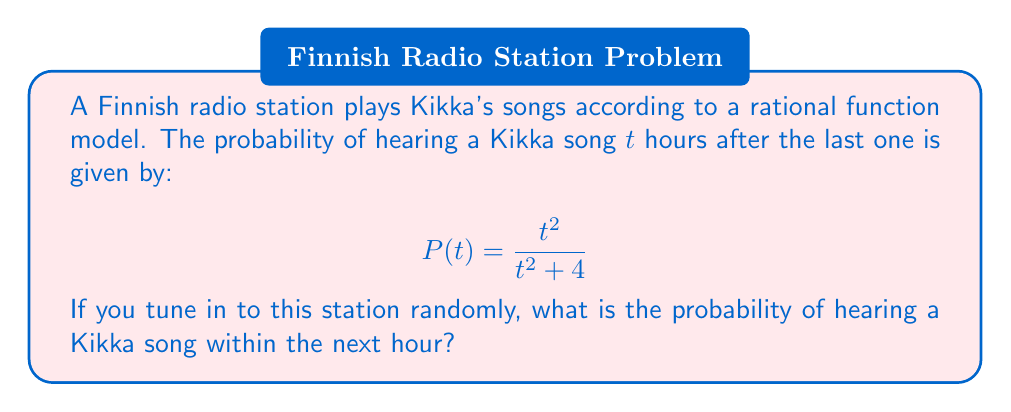Help me with this question. To solve this problem, we need to integrate the probability function over the interval from 0 to 1 hour:

1) The integral we need to calculate is:

   $$\int_0^1 P(t) dt = \int_0^1 \frac{t^2}{t^2 + 4} dt$$

2) This integral can be solved using the substitution method. Let $u = t^2 + 4$, then $du = 2t dt$ or $dt = \frac{du}{2t}$:

   $$\int_0^1 \frac{t^2}{t^2 + 4} dt = \frac{1}{2}\int_4^5 \frac{u-4}{u} du$$

3) This can be further simplified:

   $$\frac{1}{2}\int_4^5 (1 - \frac{4}{u}) du = \frac{1}{2}[u - 4\ln|u|]_4^5$$

4) Evaluating the integral:

   $$\frac{1}{2}[(5 - 4\ln5) - (4 - 4\ln4)] = \frac{1}{2}[1 - 4(\ln5 - \ln4)]$$

5) Simplify:

   $$\frac{1}{2}[1 - 4\ln(\frac{5}{4})] \approx 0.1534$$

Therefore, the probability of hearing a Kikka song within the next hour is approximately 0.1534 or 15.34%.
Answer: $\frac{1}{2}[1 - 4\ln(\frac{5}{4})] \approx 0.1534$ 